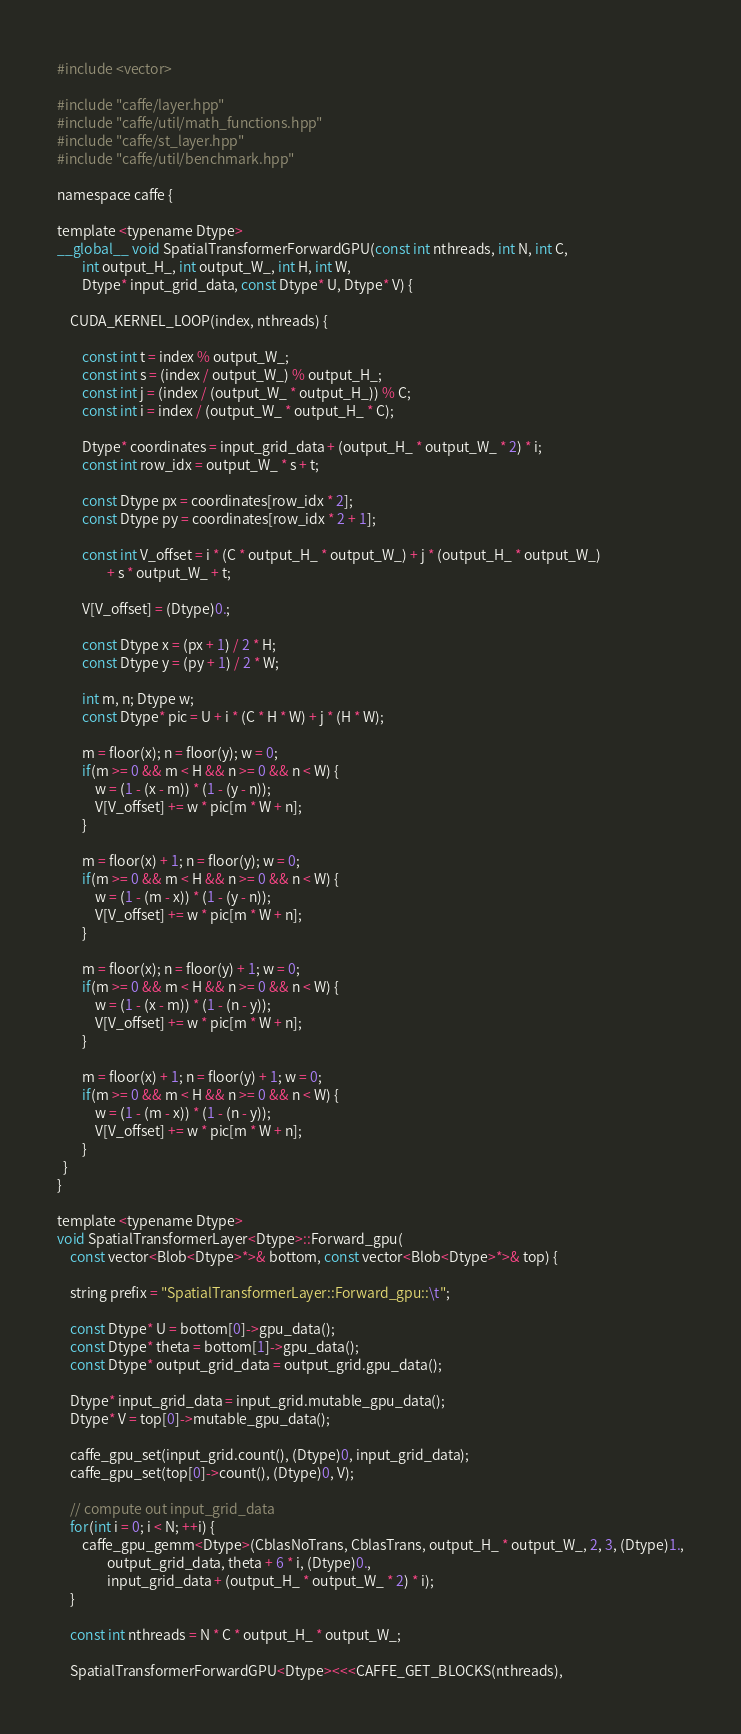Convert code to text. <code><loc_0><loc_0><loc_500><loc_500><_Cuda_>#include <vector>

#include "caffe/layer.hpp"
#include "caffe/util/math_functions.hpp"
#include "caffe/st_layer.hpp"
#include "caffe/util/benchmark.hpp"

namespace caffe {

template <typename Dtype>
__global__ void SpatialTransformerForwardGPU(const int nthreads, int N, int C,
		int output_H_, int output_W_, int H, int W,
		Dtype* input_grid_data, const Dtype* U, Dtype* V) {
	
	CUDA_KERNEL_LOOP(index, nthreads) {

		const int t = index % output_W_;
		const int s = (index / output_W_) % output_H_;
		const int j = (index / (output_W_ * output_H_)) % C;
		const int i = index / (output_W_ * output_H_ * C);

		Dtype* coordinates = input_grid_data + (output_H_ * output_W_ * 2) * i;
		const int row_idx = output_W_ * s + t;

	  	const Dtype px = coordinates[row_idx * 2];
	  	const Dtype py = coordinates[row_idx * 2 + 1];

	  	const int V_offset = i * (C * output_H_ * output_W_) + j * (output_H_ * output_W_)
	  			+ s * output_W_ + t;

	  	V[V_offset] = (Dtype)0.;

	  	const Dtype x = (px + 1) / 2 * H;
	  	const Dtype y = (py + 1) / 2 * W;

	  	int m, n; Dtype w;
	  	const Dtype* pic = U + i * (C * H * W) + j * (H * W);

	  	m = floor(x); n = floor(y); w = 0;
	  	if(m >= 0 && m < H && n >= 0 && n < W) {
	  		w = (1 - (x - m)) * (1 - (y - n));
	  		V[V_offset] += w * pic[m * W + n];
	  	}

	  	m = floor(x) + 1; n = floor(y); w = 0;
	  	if(m >= 0 && m < H && n >= 0 && n < W) {
	  		w = (1 - (m - x)) * (1 - (y - n));
	  		V[V_offset] += w * pic[m * W + n];
	  	}

	  	m = floor(x); n = floor(y) + 1; w = 0;
	  	if(m >= 0 && m < H && n >= 0 && n < W) {
	  		w = (1 - (x - m)) * (1 - (n - y));
	  		V[V_offset] += w * pic[m * W + n];
	  	}

	  	m = floor(x) + 1; n = floor(y) + 1; w = 0;
	  	if(m >= 0 && m < H && n >= 0 && n < W) {
	  		w = (1 - (m - x)) * (1 - (n - y));
	  		V[V_offset] += w * pic[m * W + n];
	  	}
  }
}

template <typename Dtype>
void SpatialTransformerLayer<Dtype>::Forward_gpu(
    const vector<Blob<Dtype>*>& bottom, const vector<Blob<Dtype>*>& top) {

	string prefix = "SpatialTransformerLayer::Forward_gpu::\t";

	const Dtype* U = bottom[0]->gpu_data();
	const Dtype* theta = bottom[1]->gpu_data();
	const Dtype* output_grid_data = output_grid.gpu_data();

	Dtype* input_grid_data = input_grid.mutable_gpu_data();
	Dtype* V = top[0]->mutable_gpu_data();

	caffe_gpu_set(input_grid.count(), (Dtype)0, input_grid_data);
	caffe_gpu_set(top[0]->count(), (Dtype)0, V);

	// compute out input_grid_data
	for(int i = 0; i < N; ++i) {
		caffe_gpu_gemm<Dtype>(CblasNoTrans, CblasTrans, output_H_ * output_W_, 2, 3, (Dtype)1.,
				output_grid_data, theta + 6 * i, (Dtype)0.,
				input_grid_data + (output_H_ * output_W_ * 2) * i);
	}

	const int nthreads = N * C * output_H_ * output_W_;

	SpatialTransformerForwardGPU<Dtype><<<CAFFE_GET_BLOCKS(nthreads),</code> 